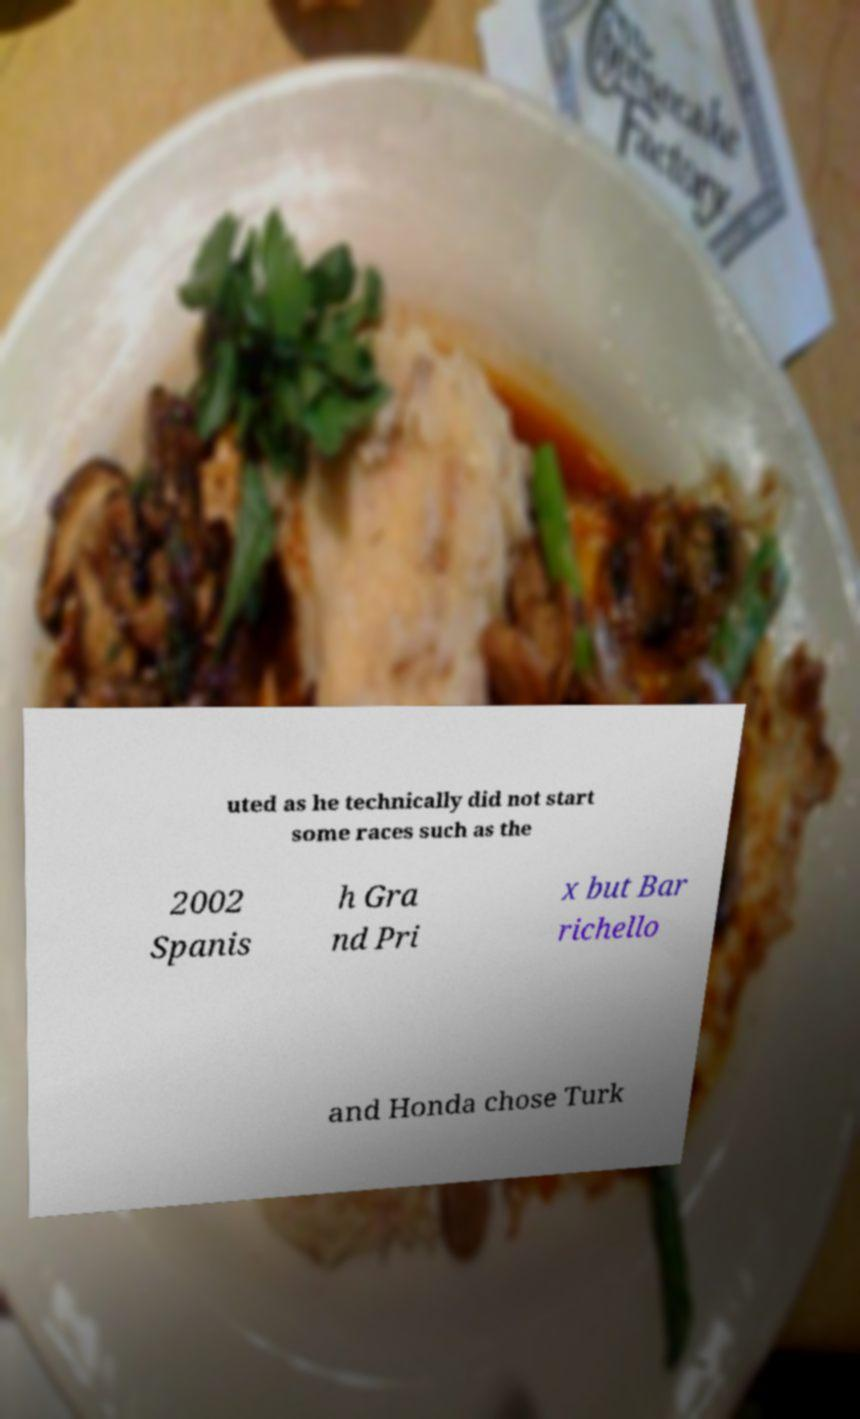What messages or text are displayed in this image? I need them in a readable, typed format. uted as he technically did not start some races such as the 2002 Spanis h Gra nd Pri x but Bar richello and Honda chose Turk 